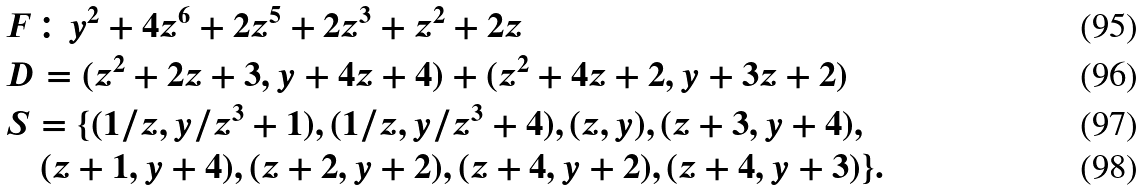Convert formula to latex. <formula><loc_0><loc_0><loc_500><loc_500>& F \colon y ^ { 2 } + 4 z ^ { 6 } + 2 z ^ { 5 } + 2 z ^ { 3 } + z ^ { 2 } + 2 z \\ & D = ( z ^ { 2 } + 2 z + 3 , y + 4 z + 4 ) + ( z ^ { 2 } + 4 z + 2 , y + 3 z + 2 ) \\ & S = \{ ( 1 / z , y / z ^ { 3 } + 1 ) , ( 1 / z , y / z ^ { 3 } + 4 ) , ( z , y ) , ( z + 3 , y + 4 ) , \\ & \quad ( z + 1 , y + 4 ) , ( z + 2 , y + 2 ) , ( z + 4 , y + 2 ) , ( z + 4 , y + 3 ) \} .</formula> 